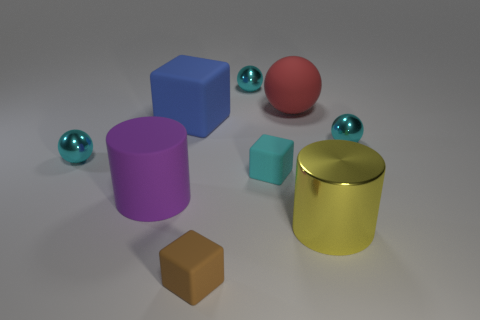Subtract all cyan cylinders. How many cyan balls are left? 3 Add 1 large brown matte things. How many objects exist? 10 Subtract all cubes. How many objects are left? 6 Subtract 1 cyan balls. How many objects are left? 8 Subtract all purple objects. Subtract all big yellow cylinders. How many objects are left? 7 Add 7 blue rubber things. How many blue rubber things are left? 8 Add 3 large matte objects. How many large matte objects exist? 6 